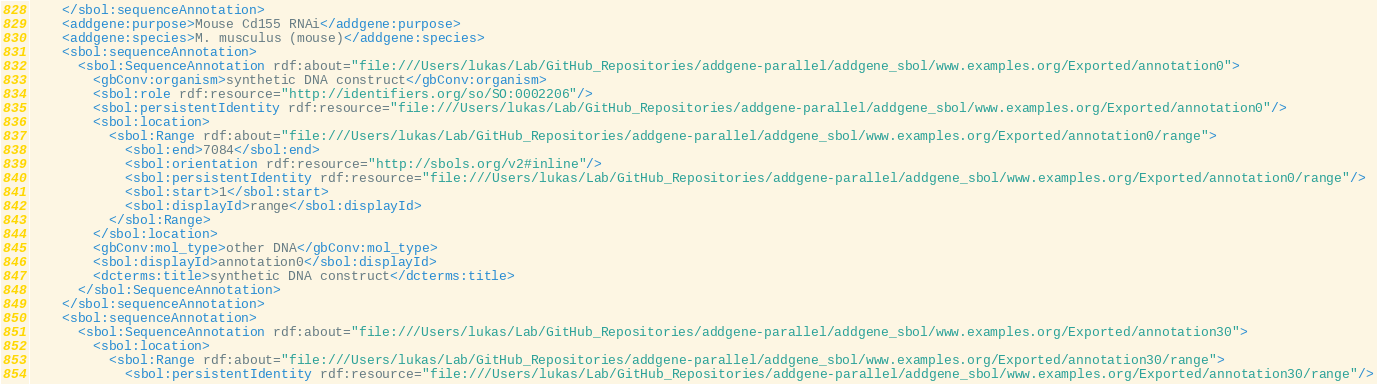<code> <loc_0><loc_0><loc_500><loc_500><_XML_>    </sbol:sequenceAnnotation>
    <addgene:purpose>Mouse Cd155 RNAi</addgene:purpose>
    <addgene:species>M. musculus (mouse)</addgene:species>
    <sbol:sequenceAnnotation>
      <sbol:SequenceAnnotation rdf:about="file:///Users/lukas/Lab/GitHub_Repositories/addgene-parallel/addgene_sbol/www.examples.org/Exported/annotation0">
        <gbConv:organism>synthetic DNA construct</gbConv:organism>
        <sbol:role rdf:resource="http://identifiers.org/so/SO:0002206"/>
        <sbol:persistentIdentity rdf:resource="file:///Users/lukas/Lab/GitHub_Repositories/addgene-parallel/addgene_sbol/www.examples.org/Exported/annotation0"/>
        <sbol:location>
          <sbol:Range rdf:about="file:///Users/lukas/Lab/GitHub_Repositories/addgene-parallel/addgene_sbol/www.examples.org/Exported/annotation0/range">
            <sbol:end>7084</sbol:end>
            <sbol:orientation rdf:resource="http://sbols.org/v2#inline"/>
            <sbol:persistentIdentity rdf:resource="file:///Users/lukas/Lab/GitHub_Repositories/addgene-parallel/addgene_sbol/www.examples.org/Exported/annotation0/range"/>
            <sbol:start>1</sbol:start>
            <sbol:displayId>range</sbol:displayId>
          </sbol:Range>
        </sbol:location>
        <gbConv:mol_type>other DNA</gbConv:mol_type>
        <sbol:displayId>annotation0</sbol:displayId>
        <dcterms:title>synthetic DNA construct</dcterms:title>
      </sbol:SequenceAnnotation>
    </sbol:sequenceAnnotation>
    <sbol:sequenceAnnotation>
      <sbol:SequenceAnnotation rdf:about="file:///Users/lukas/Lab/GitHub_Repositories/addgene-parallel/addgene_sbol/www.examples.org/Exported/annotation30">
        <sbol:location>
          <sbol:Range rdf:about="file:///Users/lukas/Lab/GitHub_Repositories/addgene-parallel/addgene_sbol/www.examples.org/Exported/annotation30/range">
            <sbol:persistentIdentity rdf:resource="file:///Users/lukas/Lab/GitHub_Repositories/addgene-parallel/addgene_sbol/www.examples.org/Exported/annotation30/range"/></code> 